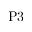<formula> <loc_0><loc_0><loc_500><loc_500>P 3</formula> 